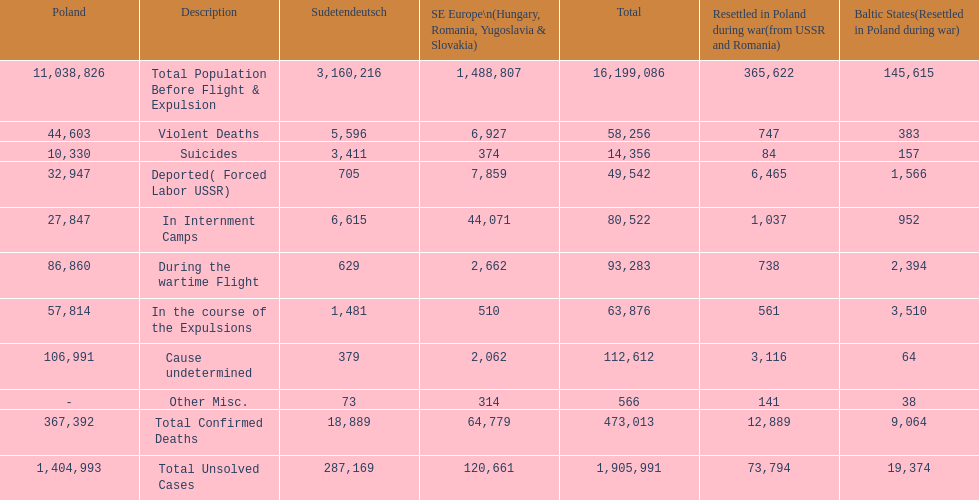Were there more cause undetermined or miscellaneous deaths in the baltic states? Cause undetermined. 